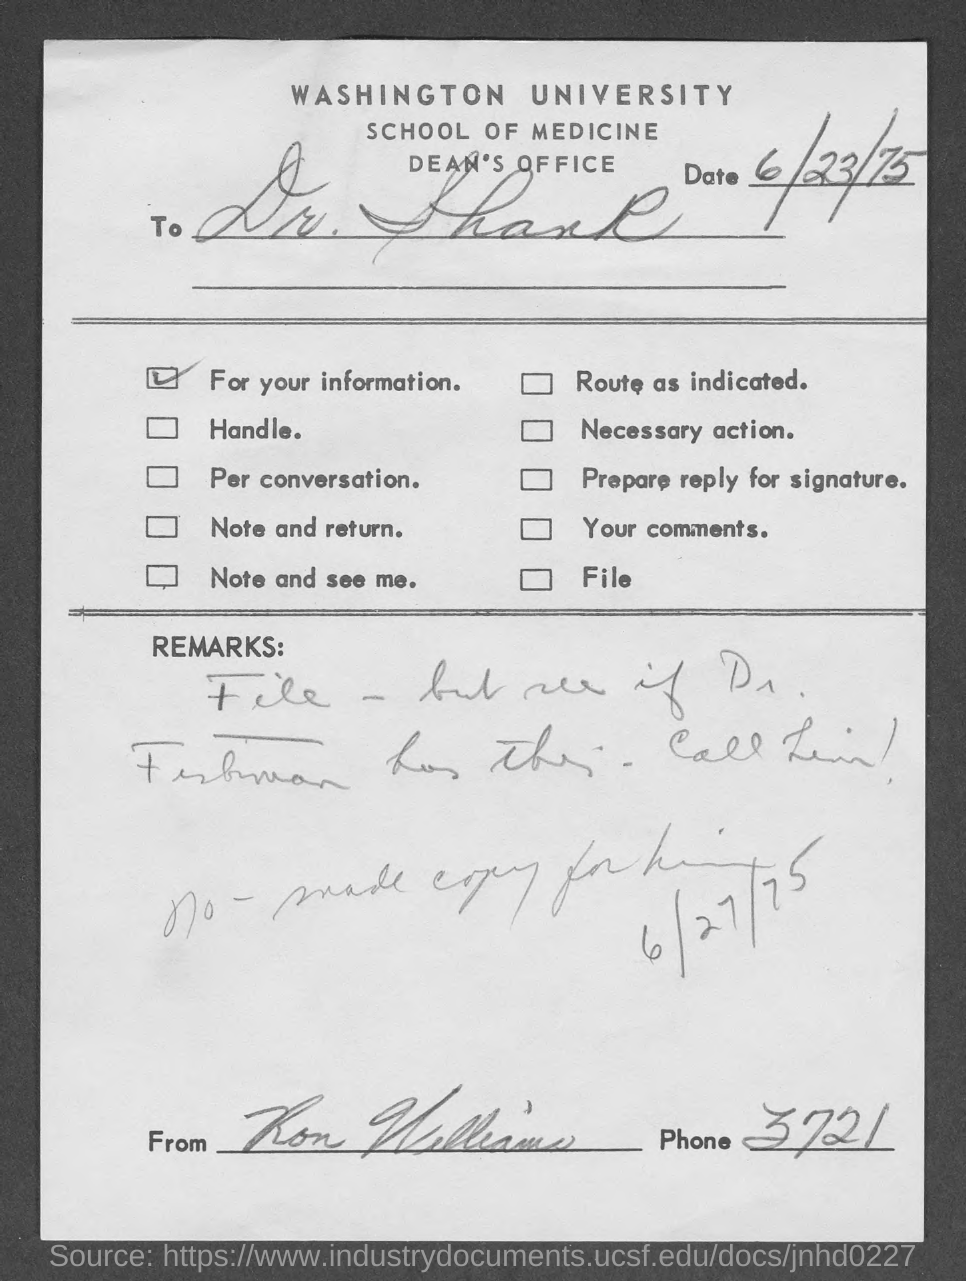What is the issued date of the document?
Offer a very short reply. 6/23/75. Which university is mentioned in the header of the document?
Your response must be concise. Washington University. 